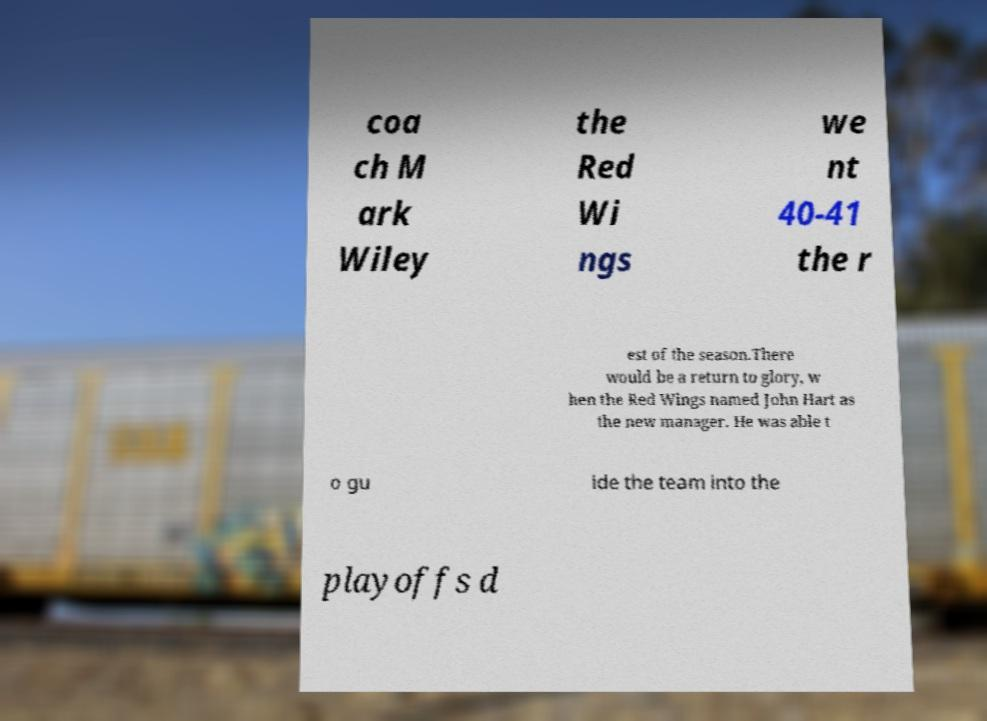Please identify and transcribe the text found in this image. coa ch M ark Wiley the Red Wi ngs we nt 40-41 the r est of the season.There would be a return to glory, w hen the Red Wings named John Hart as the new manager. He was able t o gu ide the team into the playoffs d 